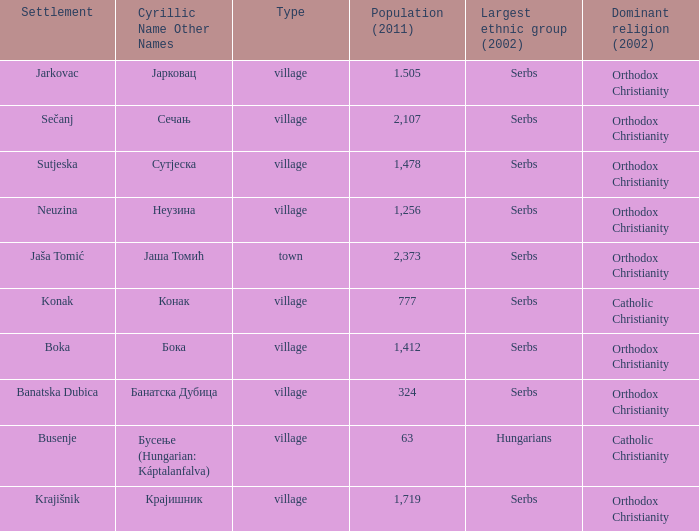The pooulation of јарковац is? 1.505. 